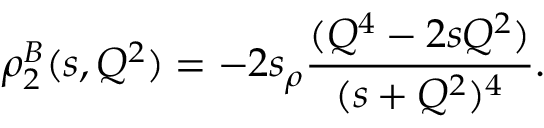<formula> <loc_0><loc_0><loc_500><loc_500>\rho _ { 2 } ^ { B } ( s , Q ^ { 2 } ) = - 2 s _ { \rho } \frac { ( Q ^ { 4 } - 2 s Q ^ { 2 } ) } { ( s + Q ^ { 2 } ) ^ { 4 } } .</formula> 